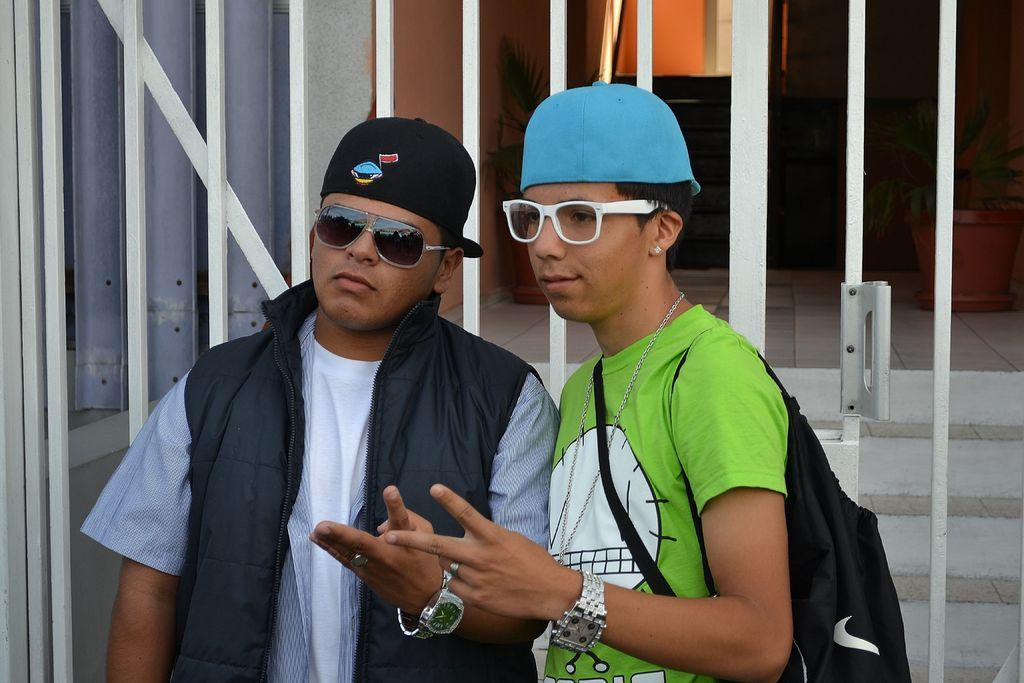How many people are in the image? There are two men in the image. What are the men wearing on their faces? Both men are wearing spectacles. What type of headwear are the men wearing? Both men are wearing caps on their heads. What can be seen in the background of the image? There is a white color gate in the background of the image. Can you see the ocean in the image? No, the ocean is not present in the image. What system is being used by the men to communicate with each other? There is no indication of a communication system in the image; the men are simply standing together. 